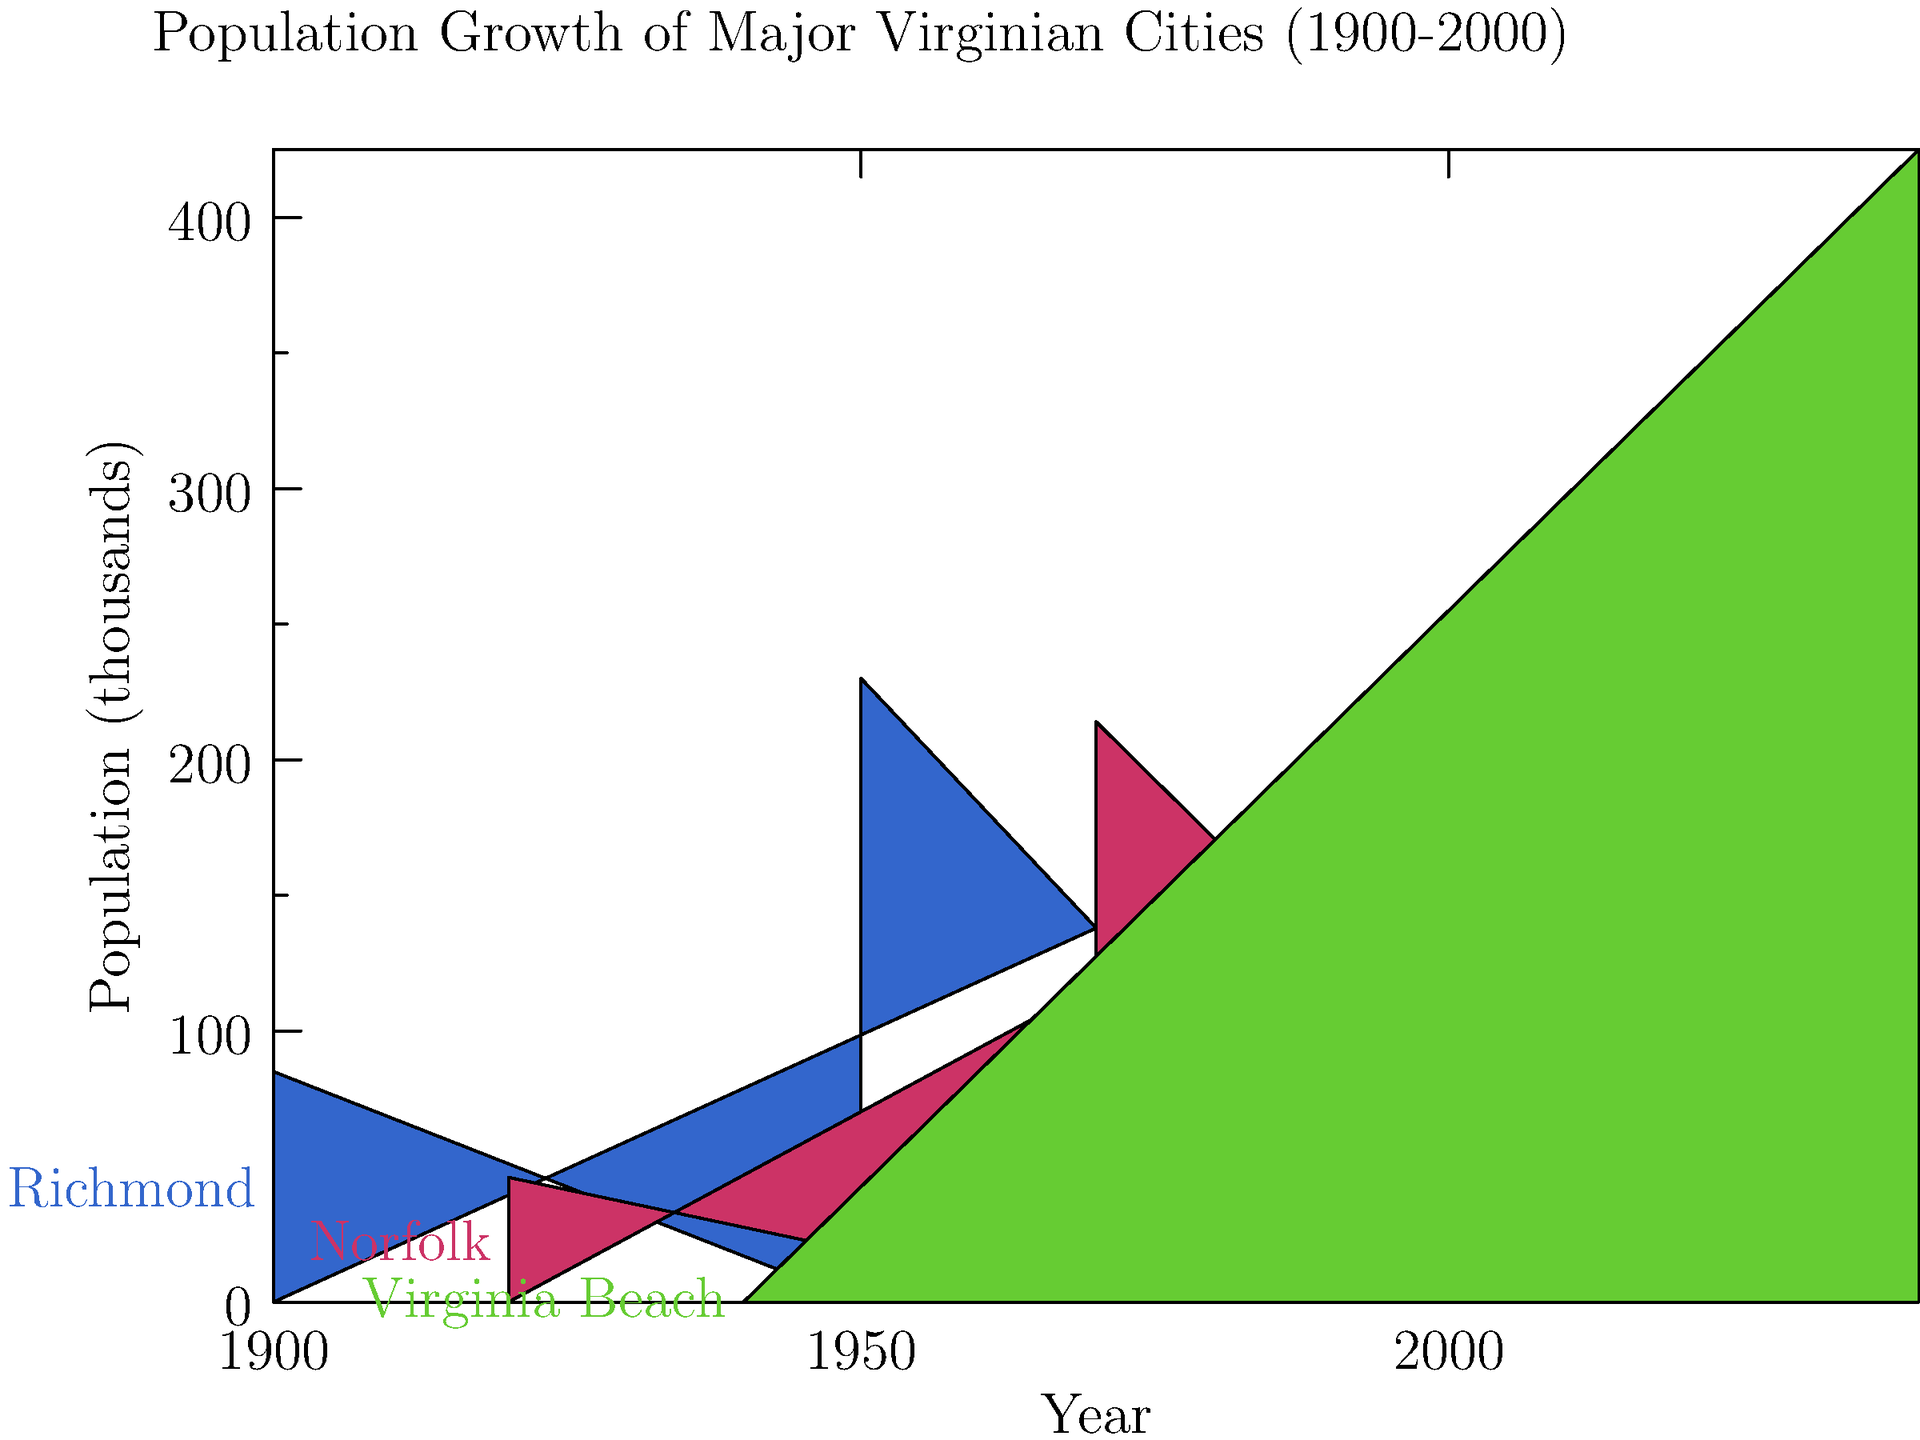Based on the bar graph showing population growth in major Virginian cities from 1900 to 2000, which city experienced the most significant change in its growth pattern between 1950 and 2000? To answer this question, we need to analyze the population changes for each city between 1950 and 2000:

1. Richmond:
   - 1950 population: 230,000
   - 2000 population: 197,000
   - Change: Decrease of 33,000

2. Norfolk:
   - 1950 population: 214,000
   - 2000 population: 234,000
   - Change: Increase of 20,000

3. Virginia Beach:
   - 1950 population: 0 (not shown as a major city)
   - 2000 population: 425,000
   - Change: Increase of 425,000

Virginia Beach shows the most significant change in its growth pattern. It went from not being considered a major city in 1950 to becoming the most populous of the three by 2000, with a dramatic increase of 425,000 residents.

This growth is likely due to factors such as:
1. The merger of Virginia Beach with Princess Anne County in 1963
2. Suburban expansion
3. Economic development, particularly in tourism and military sectors

The change in Virginia Beach's growth pattern is much more substantial than the relatively minor changes seen in Richmond and Norfolk during the same period.
Answer: Virginia Beach 